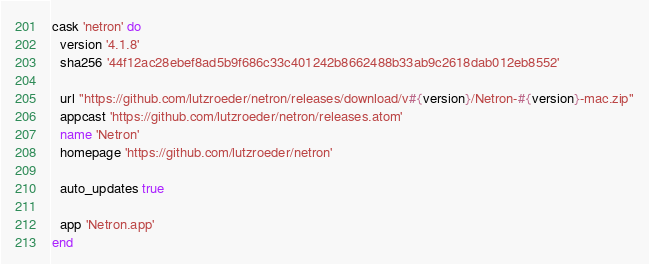Convert code to text. <code><loc_0><loc_0><loc_500><loc_500><_Ruby_>cask 'netron' do
  version '4.1.8'
  sha256 '44f12ac28ebef8ad5b9f686c33c401242b8662488b33ab9c2618dab012eb8552'

  url "https://github.com/lutzroeder/netron/releases/download/v#{version}/Netron-#{version}-mac.zip"
  appcast 'https://github.com/lutzroeder/netron/releases.atom'
  name 'Netron'
  homepage 'https://github.com/lutzroeder/netron'

  auto_updates true

  app 'Netron.app'
end
</code> 